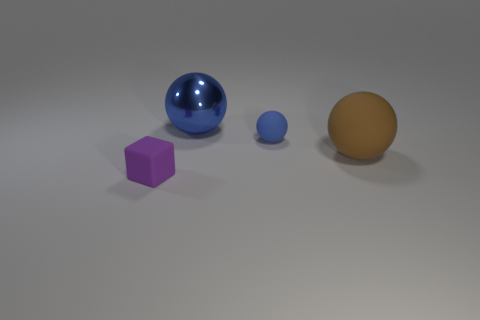Is the number of large things in front of the shiny thing the same as the number of blue spheres? The answer is no. Upon examining the image, we can see one large brown sphere and a purple cube in front of the shiny blue sphere. Therefore, the two blue spheres do not have the same number of large objects in front of them as there are only two objects, and they are not both spheres. 